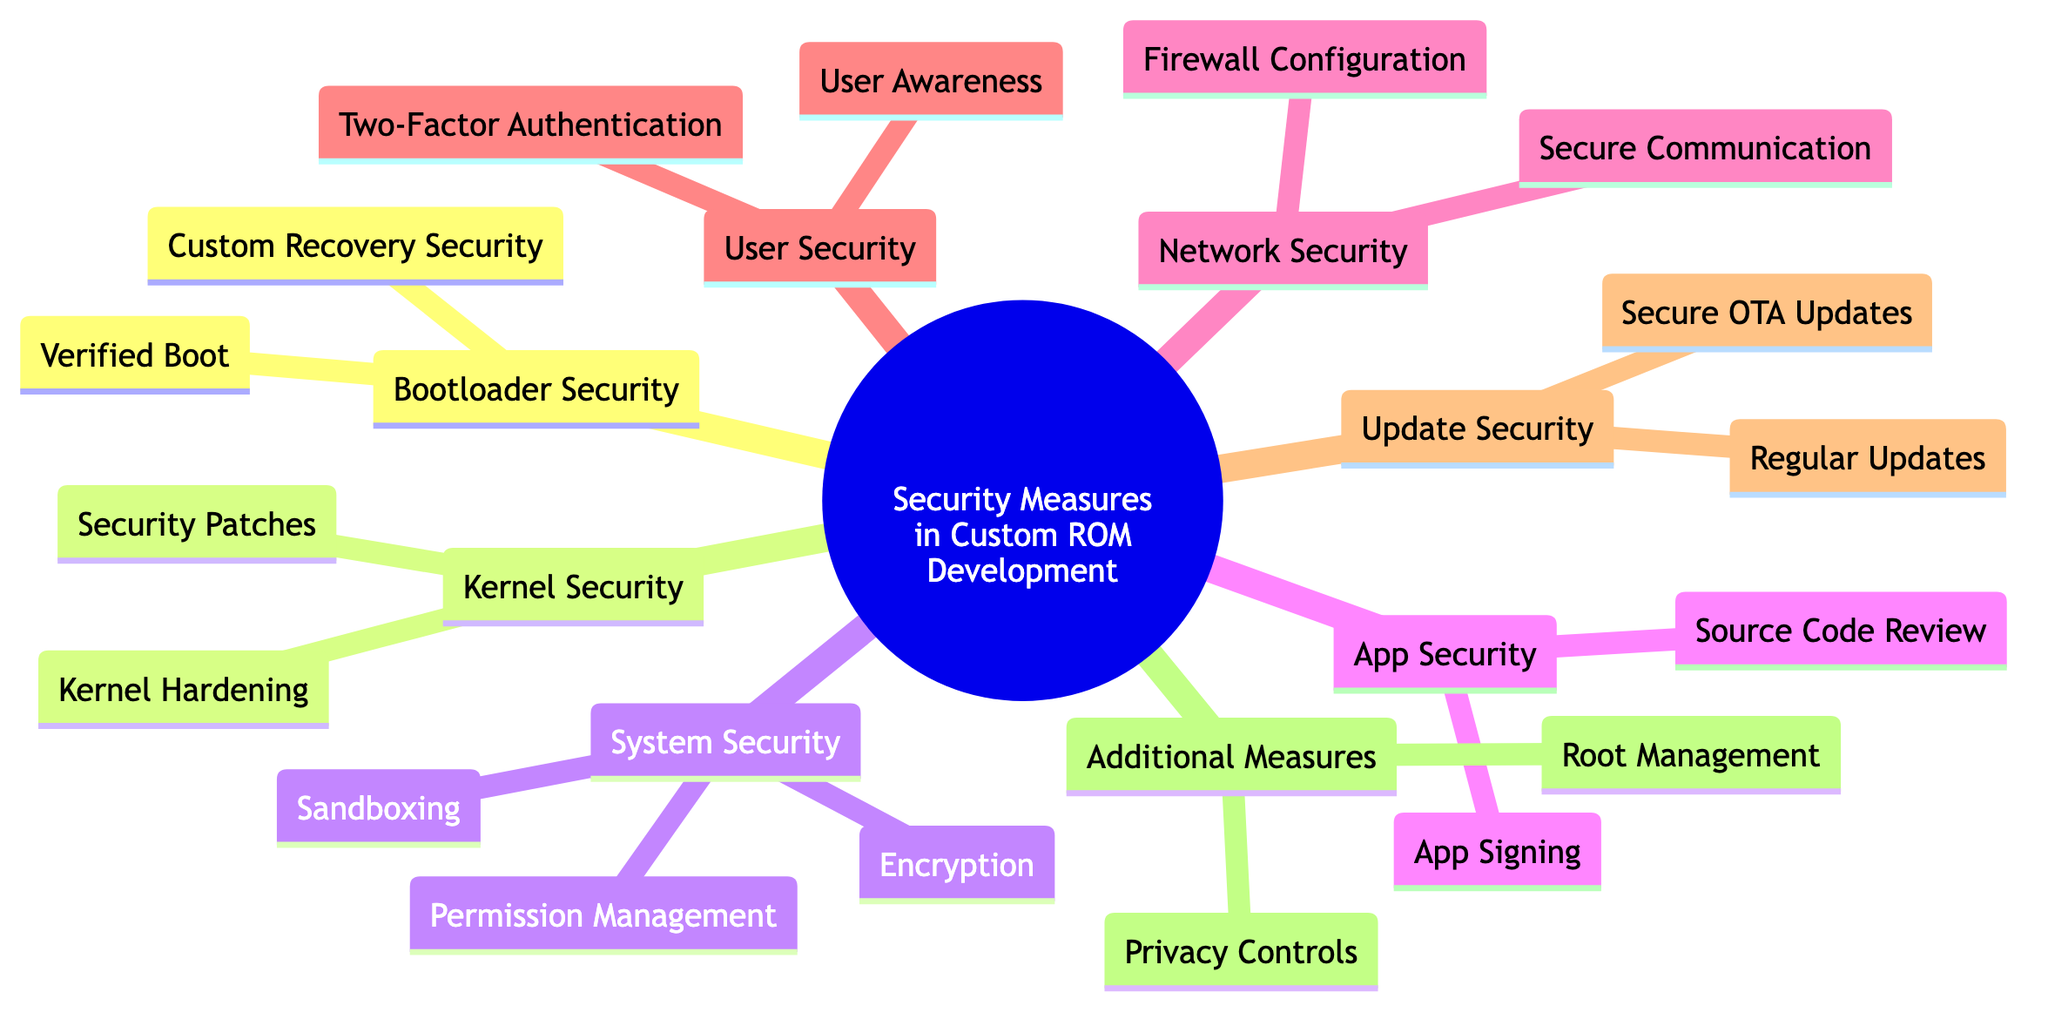What are the two main aspects of Bootloader Security? Bootloader Security consists of Verified Boot and Custom Recovery Security, which are both listed as child nodes under the Bootloader Security node in the diagram.
Answer: Verified Boot, Custom Recovery Security How many main categories of security measures are there in the diagram? The diagram outlines 8 main categories of security measures, each represented as a primary node stemming from the root node concerned with Security Measures in Custom ROM Development.
Answer: 8 What is included in the System Security category? The System Security category includes three elements: Permission Management, Sandboxing, and Encryption, which can be found listed under the System Security node.
Answer: Permission Management, Sandboxing, Encryption What type of security is implemented for critical operations according to User Security? According to User Security, Two-Factor Authentication is implemented for critical operations explicitly mentioned under the User Security node.
Answer: Two-Factor Authentication What are the two focuses of Network Security? The Network Security category comprises Firewall Configuration and Secure Communication as its two main aspects, which are directly listed under the Network Security node.
Answer: Firewall Configuration, Secure Communication Why is Kernel Hardening important in Kernel Security? Kernel Hardening is crucial in Kernel Security as it includes enabling SELinux and ASLR, which enhance the kernel's security posture and mitigate vulnerabilities. Both are part of the dedicated section under Kernel Security.
Answer: Enhances security Which security measure recommends integrating privacy controls? The Additional Measures section recommends integrating Privacy Controls, which focuses on features that protect user privacy. This is specifically mentioned as part of the Additional Measures node.
Answer: Privacy Controls What is the purpose of Secure OTA Updates? The purpose of Secure OTA Updates is to ensure that the updates delivered to users are signed and verified, as indicated under the Update Security category in the mind map.
Answer: Use signed and verified OTA packages How often should Security Patches be integrated? The recommendation is to regularly integrate the latest kernel patches to maintain Kernel Security, as stated under the corresponding node in the diagram.
Answer: Regularly 